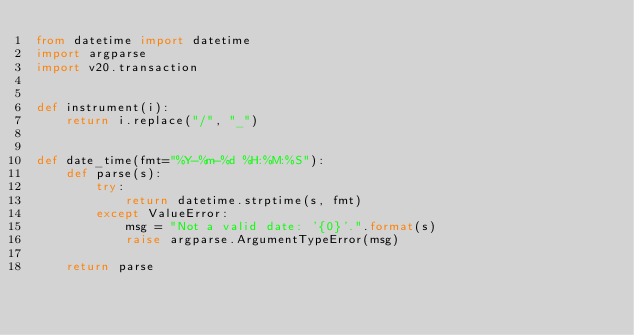<code> <loc_0><loc_0><loc_500><loc_500><_Python_>from datetime import datetime
import argparse
import v20.transaction


def instrument(i):
    return i.replace("/", "_")


def date_time(fmt="%Y-%m-%d %H:%M:%S"):
    def parse(s):
        try:
            return datetime.strptime(s, fmt)
        except ValueError:
            msg = "Not a valid date: '{0}'.".format(s)
            raise argparse.ArgumentTypeError(msg)

    return parse
</code> 